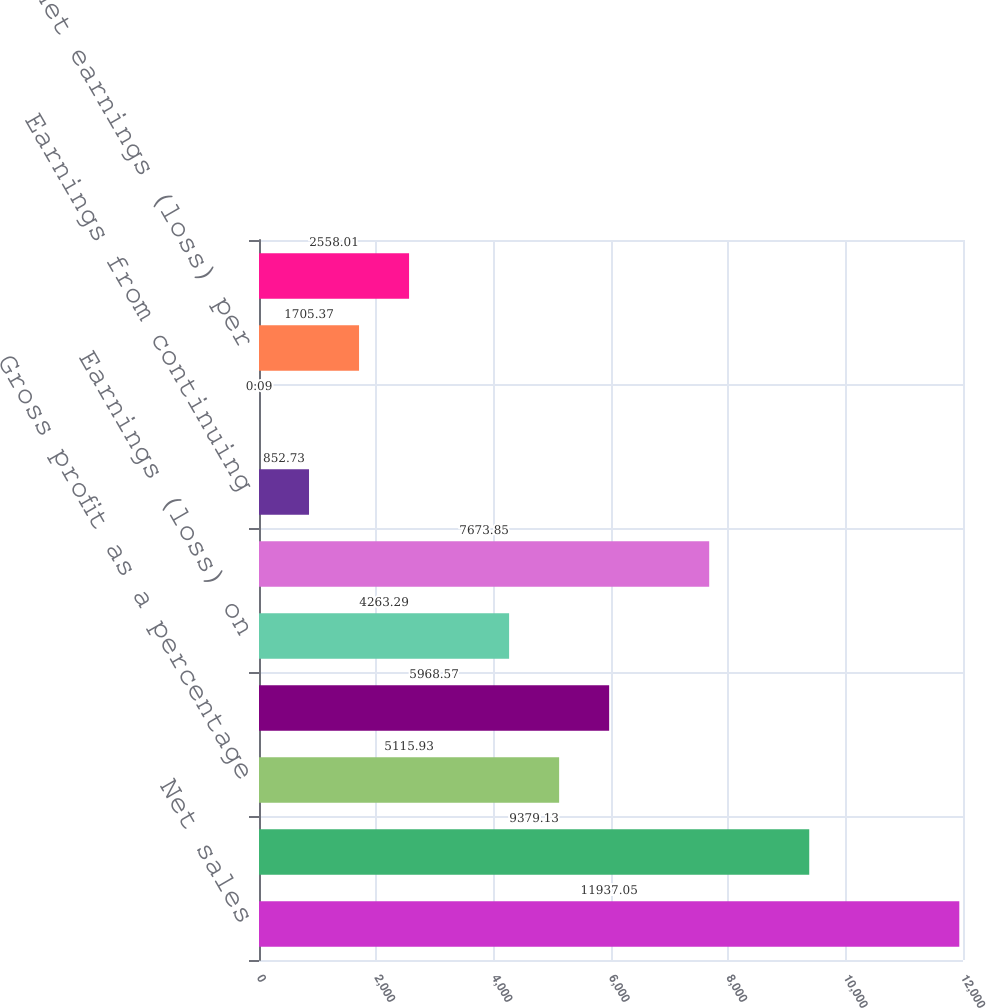<chart> <loc_0><loc_0><loc_500><loc_500><bar_chart><fcel>Net sales<fcel>Gross profit<fcel>Gross profit as a percentage<fcel>Earnings (loss) from<fcel>Earnings (loss) on<fcel>Net earnings (loss)<fcel>Earnings from continuing<fcel>Discontinued operations<fcel>Basic net earnings (loss) per<fcel>Diluted net earnings (loss)<nl><fcel>11937<fcel>9379.13<fcel>5115.93<fcel>5968.57<fcel>4263.29<fcel>7673.85<fcel>852.73<fcel>0.09<fcel>1705.37<fcel>2558.01<nl></chart> 